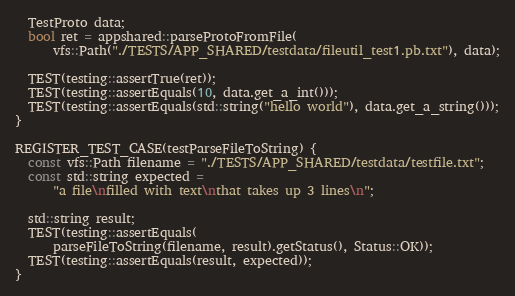Convert code to text. <code><loc_0><loc_0><loc_500><loc_500><_C++_>  TestProto data;
  bool ret = appshared::parseProtoFromFile(
      vfs::Path("./TESTS/APP_SHARED/testdata/fileutil_test1.pb.txt"), data);

  TEST(testing::assertTrue(ret));
  TEST(testing::assertEquals(10, data.get_a_int()));
  TEST(testing::assertEquals(std::string("hello world"), data.get_a_string()));
}

REGISTER_TEST_CASE(testParseFileToString) {
  const vfs::Path filename = "./TESTS/APP_SHARED/testdata/testfile.txt";
  const std::string expected =
      "a file\nfilled with text\nthat takes up 3 lines\n";

  std::string result;
  TEST(testing::assertEquals(
      parseFileToString(filename, result).getStatus(), Status::OK));
  TEST(testing::assertEquals(result, expected));
}
</code> 